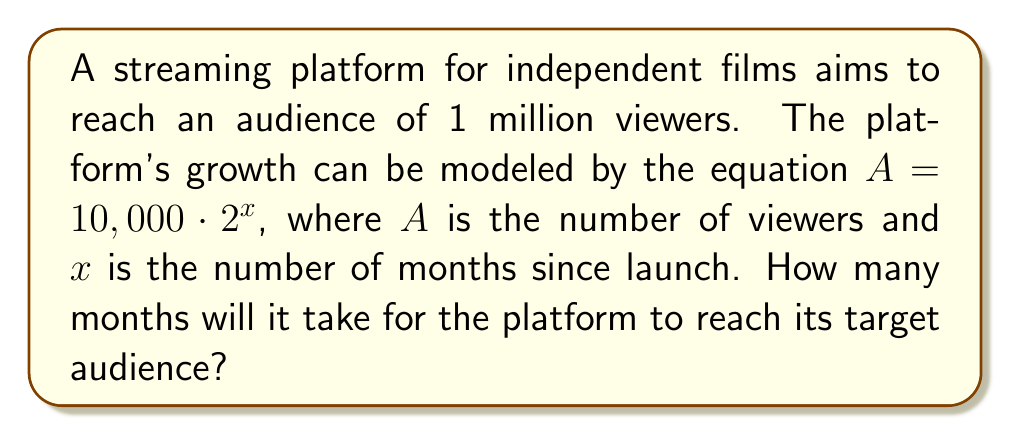Can you solve this math problem? To solve this problem, we'll use logarithms to isolate the variable $x$. Here's the step-by-step process:

1) We start with the given equation: $A = 10,000 \cdot 2^x$

2) We know that the target audience $A$ is 1 million, or 1,000,000. Let's substitute this:

   $1,000,000 = 10,000 \cdot 2^x$

3) Divide both sides by 10,000:

   $100 = 2^x$

4) Now, we can apply the logarithm (base 2) to both sides:

   $\log_2(100) = \log_2(2^x)$

5) Using the logarithm property $\log_a(a^x) = x$, we get:

   $\log_2(100) = x$

6) To calculate $\log_2(100)$, we can use the change of base formula:

   $x = \log_2(100) = \frac{\log(100)}{\log(2)} \approx 6.64386$

7) Since we can't have a fractional number of months, we need to round up to the nearest whole number.

Therefore, it will take 7 months for the platform to reach its target audience.
Answer: 7 months 